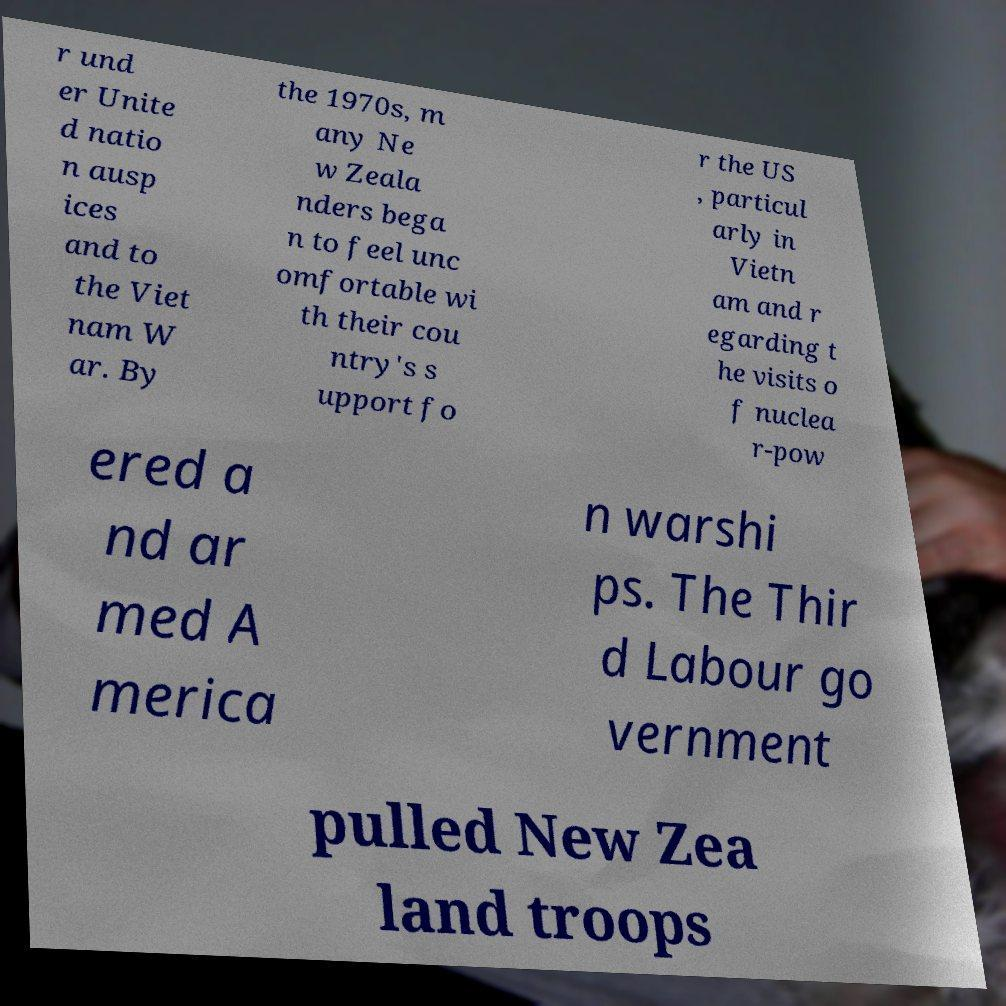For documentation purposes, I need the text within this image transcribed. Could you provide that? r und er Unite d natio n ausp ices and to the Viet nam W ar. By the 1970s, m any Ne w Zeala nders bega n to feel unc omfortable wi th their cou ntry's s upport fo r the US , particul arly in Vietn am and r egarding t he visits o f nuclea r-pow ered a nd ar med A merica n warshi ps. The Thir d Labour go vernment pulled New Zea land troops 